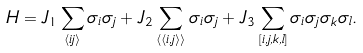Convert formula to latex. <formula><loc_0><loc_0><loc_500><loc_500>H = J _ { 1 } \sum _ { \langle i j \rangle } \sigma _ { i } \sigma _ { j } + J _ { 2 } \sum _ { \langle \langle i , j \rangle \rangle } \sigma _ { i } \sigma _ { j } + J _ { 3 } \sum _ { [ i , j , k , l ] } \sigma _ { i } \sigma _ { j } \sigma _ { k } \sigma _ { l } .</formula> 